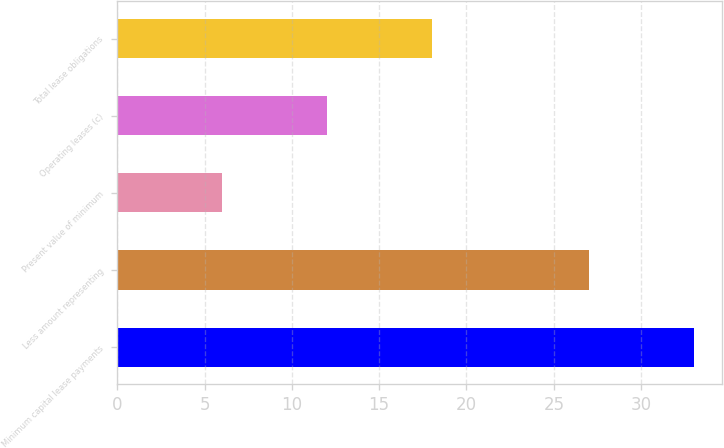<chart> <loc_0><loc_0><loc_500><loc_500><bar_chart><fcel>Minimum capital lease payments<fcel>Less amount representing<fcel>Present value of minimum<fcel>Operating leases (c)<fcel>Total lease obligations<nl><fcel>33<fcel>27<fcel>6<fcel>12<fcel>18<nl></chart> 